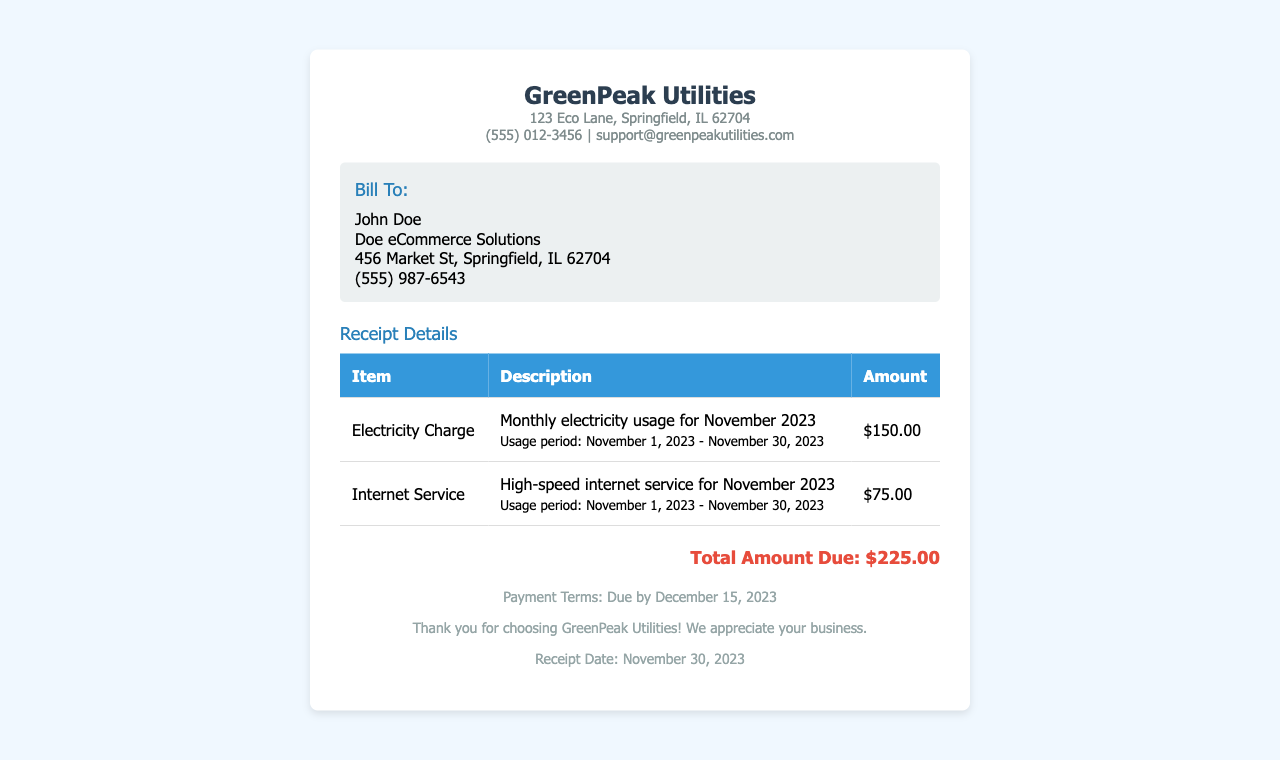What is the total amount due? The total amount due is calculated by adding the electricity charge and internet service fee, which equals $150.00 + $75.00.
Answer: $225.00 Who is the bill recipient? The bill recipient is identified in the 'Bill To' section of the receipt.
Answer: John Doe What is the electricity charge amount? The document specifies the electricity charge amount in the table under 'Amount' for Electricity Charge.
Answer: $150.00 What is the payment due date? The payment due date is mentioned in the footer section of the receipt.
Answer: December 15, 2023 What was the usage period for the internet service? The usage period is noted in the description of the internet service charge in the document.
Answer: November 1, 2023 - November 30, 2023 Where is the company located? The company location is detailed in the company details section at the top of the receipt.
Answer: 123 Eco Lane, Springfield, IL 62704 What is included in the customer details? The customer details section includes the customer's name, business name, address, and phone number.
Answer: Doe eCommerce Solutions What service type does the receipt pertain to? The receipt type reflects the services performed for this specific billing period, as shown in the table.
Answer: Utilities How many items are listed in the receipt? The number of items is indicated in the table, which shows the different charges listed.
Answer: 2 